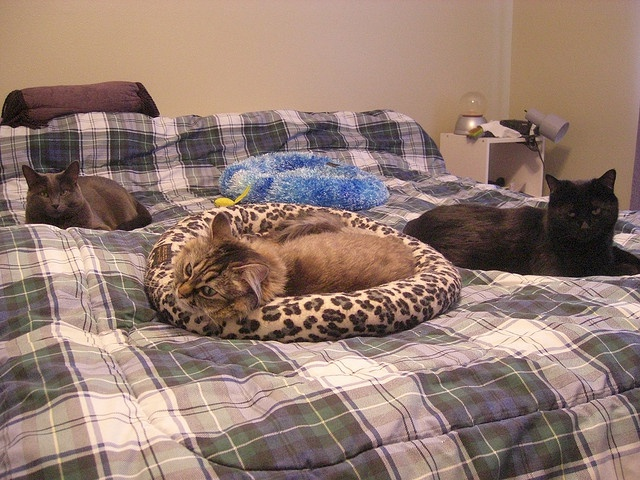Describe the objects in this image and their specific colors. I can see bed in tan, gray, and darkgray tones, cat in tan, gray, maroon, and brown tones, cat in tan, black, gray, and maroon tones, and cat in tan, black, maroon, and brown tones in this image. 